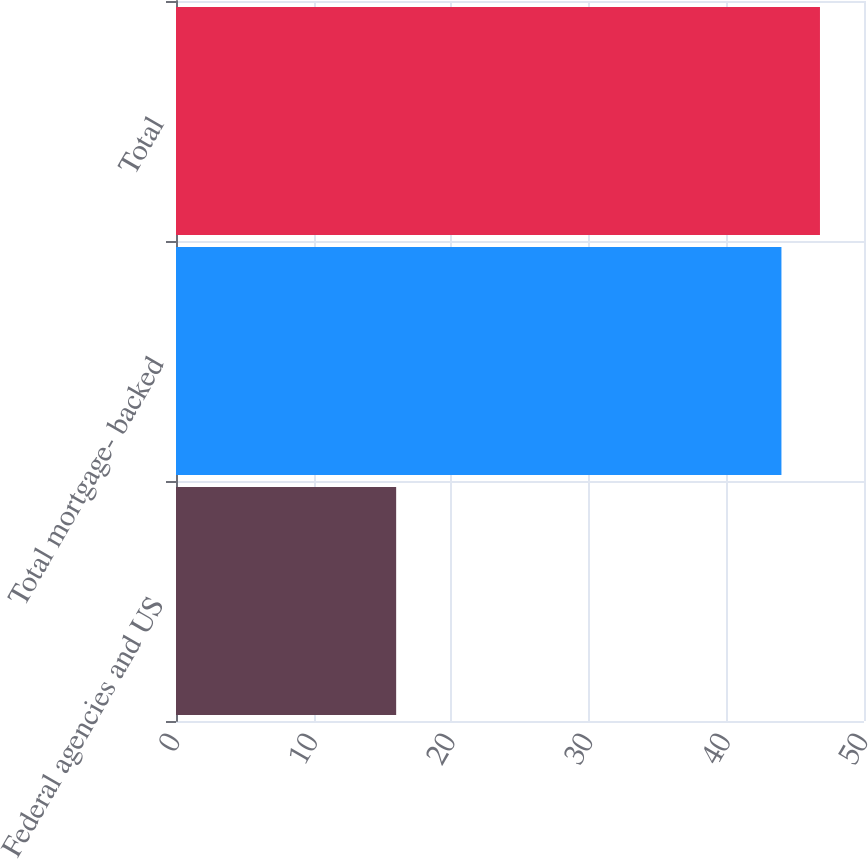Convert chart to OTSL. <chart><loc_0><loc_0><loc_500><loc_500><bar_chart><fcel>Federal agencies and US<fcel>Total mortgage- backed<fcel>Total<nl><fcel>16<fcel>44<fcel>46.8<nl></chart> 